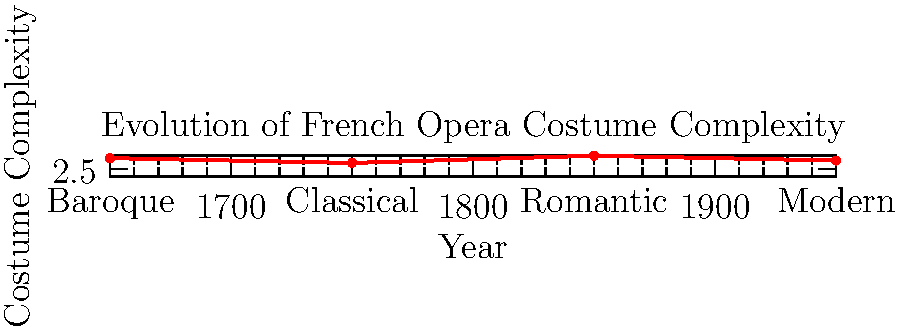Based on the graph depicting the evolution of French opera costume complexity over time, which era showed the highest level of intricacy in costume design, and how might this reflect the broader artistic trends of that period? To answer this question, let's analyze the graph step-by-step:

1. The graph shows the costume complexity for four major eras in opera history: Baroque (1650), Classical (1750), Romantic (1850), and Modern (1950).

2. The y-axis represents costume complexity on a scale from 0 to 10.

3. Examining the data points:
   - Baroque era (1650): complexity score of 7
   - Classical era (1750): complexity score of 5
   - Romantic era (1850): complexity score of 8
   - Modern era (1950): complexity score of 6

4. The highest point on the graph corresponds to the Romantic era (1850) with a complexity score of 8.

5. This peak in costume complexity during the Romantic era reflects broader artistic trends of the time:
   - Emphasis on emotion, imagination, and individualism
   - Desire for grand, elaborate productions
   - Interest in historical accuracy and exotic settings
   - Technological advancements in stage machinery and lighting

6. The increased complexity in Romantic era costumes likely involved:
   - More detailed embroidery and embellishments
   - Use of a wider range of fabrics and textures
   - Incorporation of historical and fantastical elements
   - Greater attention to character-specific designs

7. This trend aligns with the overall aesthetic of Romantic opera, which favored spectacle and emotional intensity over the relative simplicity of the Classical period.
Answer: Romantic era (1850); reflects emphasis on emotion, grandeur, and historical detail in art. 